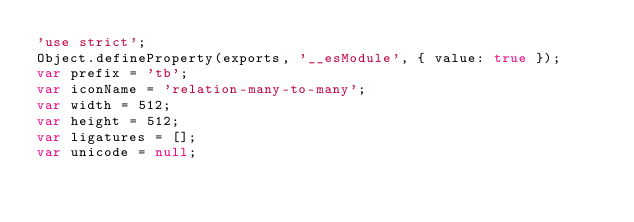Convert code to text. <code><loc_0><loc_0><loc_500><loc_500><_JavaScript_>'use strict';
Object.defineProperty(exports, '__esModule', { value: true });
var prefix = 'tb';
var iconName = 'relation-many-to-many';
var width = 512;
var height = 512;
var ligatures = [];
var unicode = null;</code> 